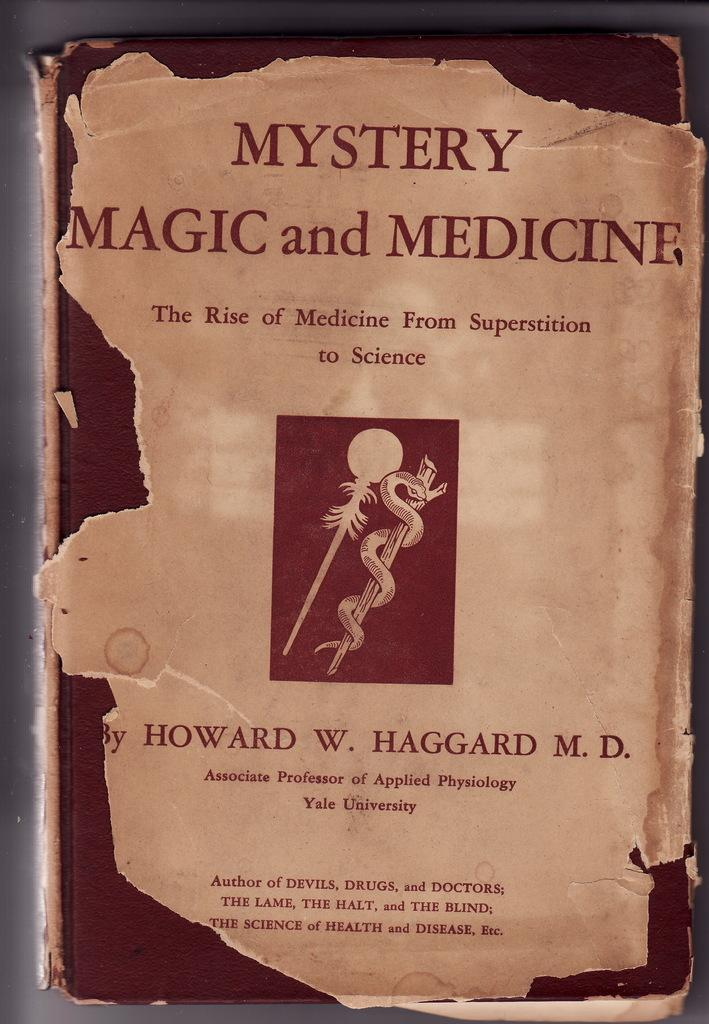<image>
Create a compact narrative representing the image presented. The front cover of a book about magic and medicine is torn around the edges. 